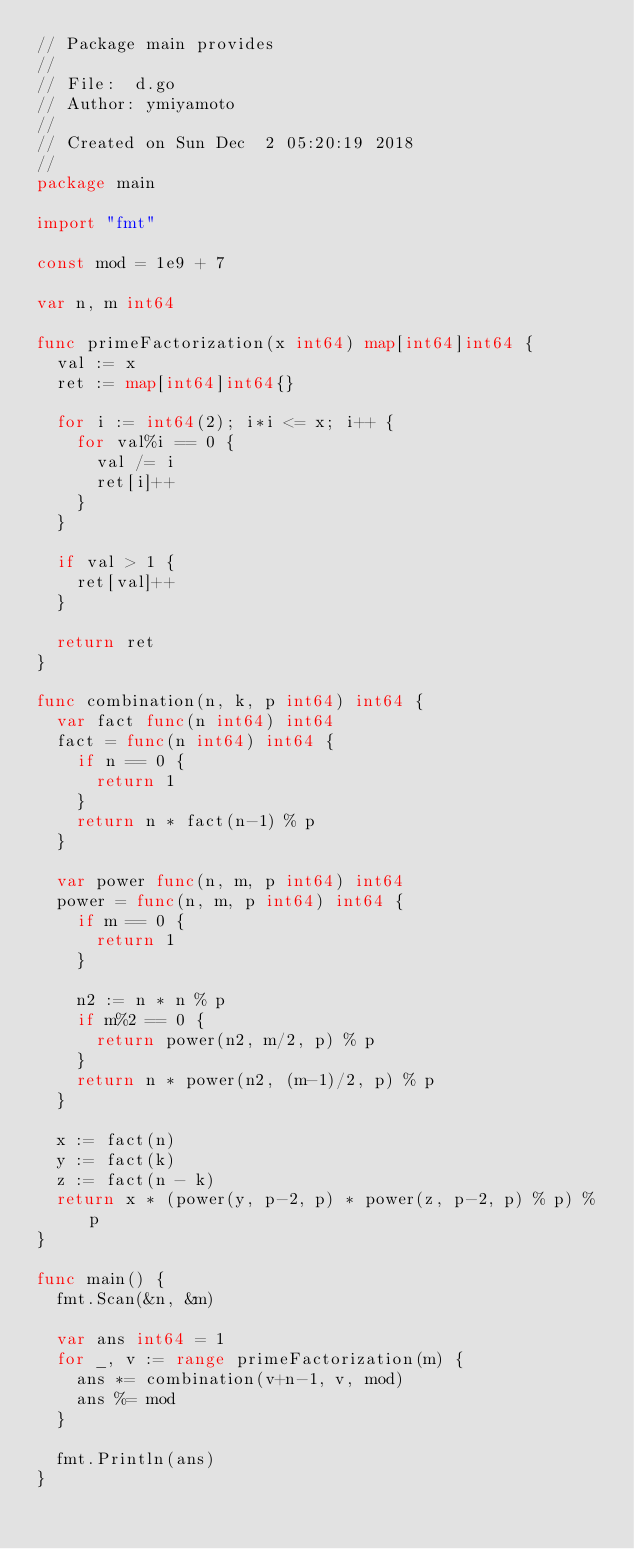<code> <loc_0><loc_0><loc_500><loc_500><_Go_>// Package main provides
//
// File:  d.go
// Author: ymiyamoto
//
// Created on Sun Dec  2 05:20:19 2018
//
package main

import "fmt"

const mod = 1e9 + 7

var n, m int64

func primeFactorization(x int64) map[int64]int64 {
	val := x
	ret := map[int64]int64{}

	for i := int64(2); i*i <= x; i++ {
		for val%i == 0 {
			val /= i
			ret[i]++
		}
	}

	if val > 1 {
		ret[val]++
	}

	return ret
}

func combination(n, k, p int64) int64 {
	var fact func(n int64) int64
	fact = func(n int64) int64 {
		if n == 0 {
			return 1
		}
		return n * fact(n-1) % p
	}

	var power func(n, m, p int64) int64
	power = func(n, m, p int64) int64 {
		if m == 0 {
			return 1
		}

		n2 := n * n % p
		if m%2 == 0 {
			return power(n2, m/2, p) % p
		}
		return n * power(n2, (m-1)/2, p) % p
	}

	x := fact(n)
	y := fact(k)
	z := fact(n - k)
	return x * (power(y, p-2, p) * power(z, p-2, p) % p) % p
}

func main() {
	fmt.Scan(&n, &m)

	var ans int64 = 1
	for _, v := range primeFactorization(m) {
		ans *= combination(v+n-1, v, mod)
		ans %= mod
	}

	fmt.Println(ans)
}
</code> 